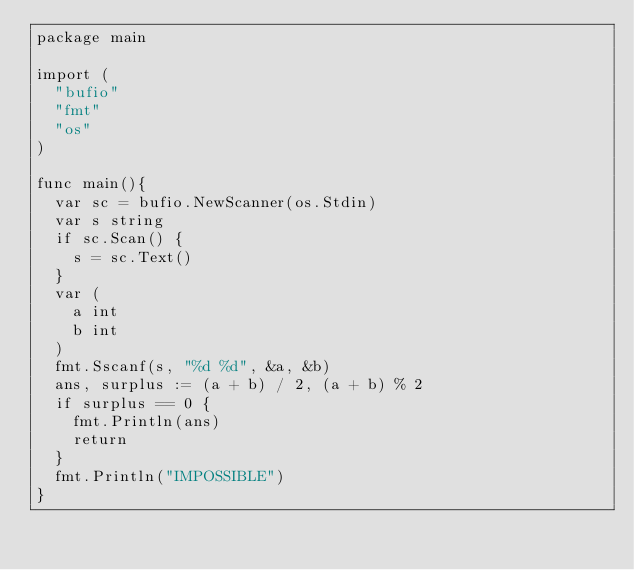<code> <loc_0><loc_0><loc_500><loc_500><_Go_>package main

import (
	"bufio"
	"fmt"
	"os"
)

func main(){
	var sc = bufio.NewScanner(os.Stdin)
	var s string
	if sc.Scan() {
		s = sc.Text()
	}
	var (
		a int
		b int
	)
	fmt.Sscanf(s, "%d %d", &a, &b)
	ans, surplus := (a + b) / 2, (a + b) % 2
	if surplus == 0 {
		fmt.Println(ans)
		return
	}
	fmt.Println("IMPOSSIBLE")
}
</code> 